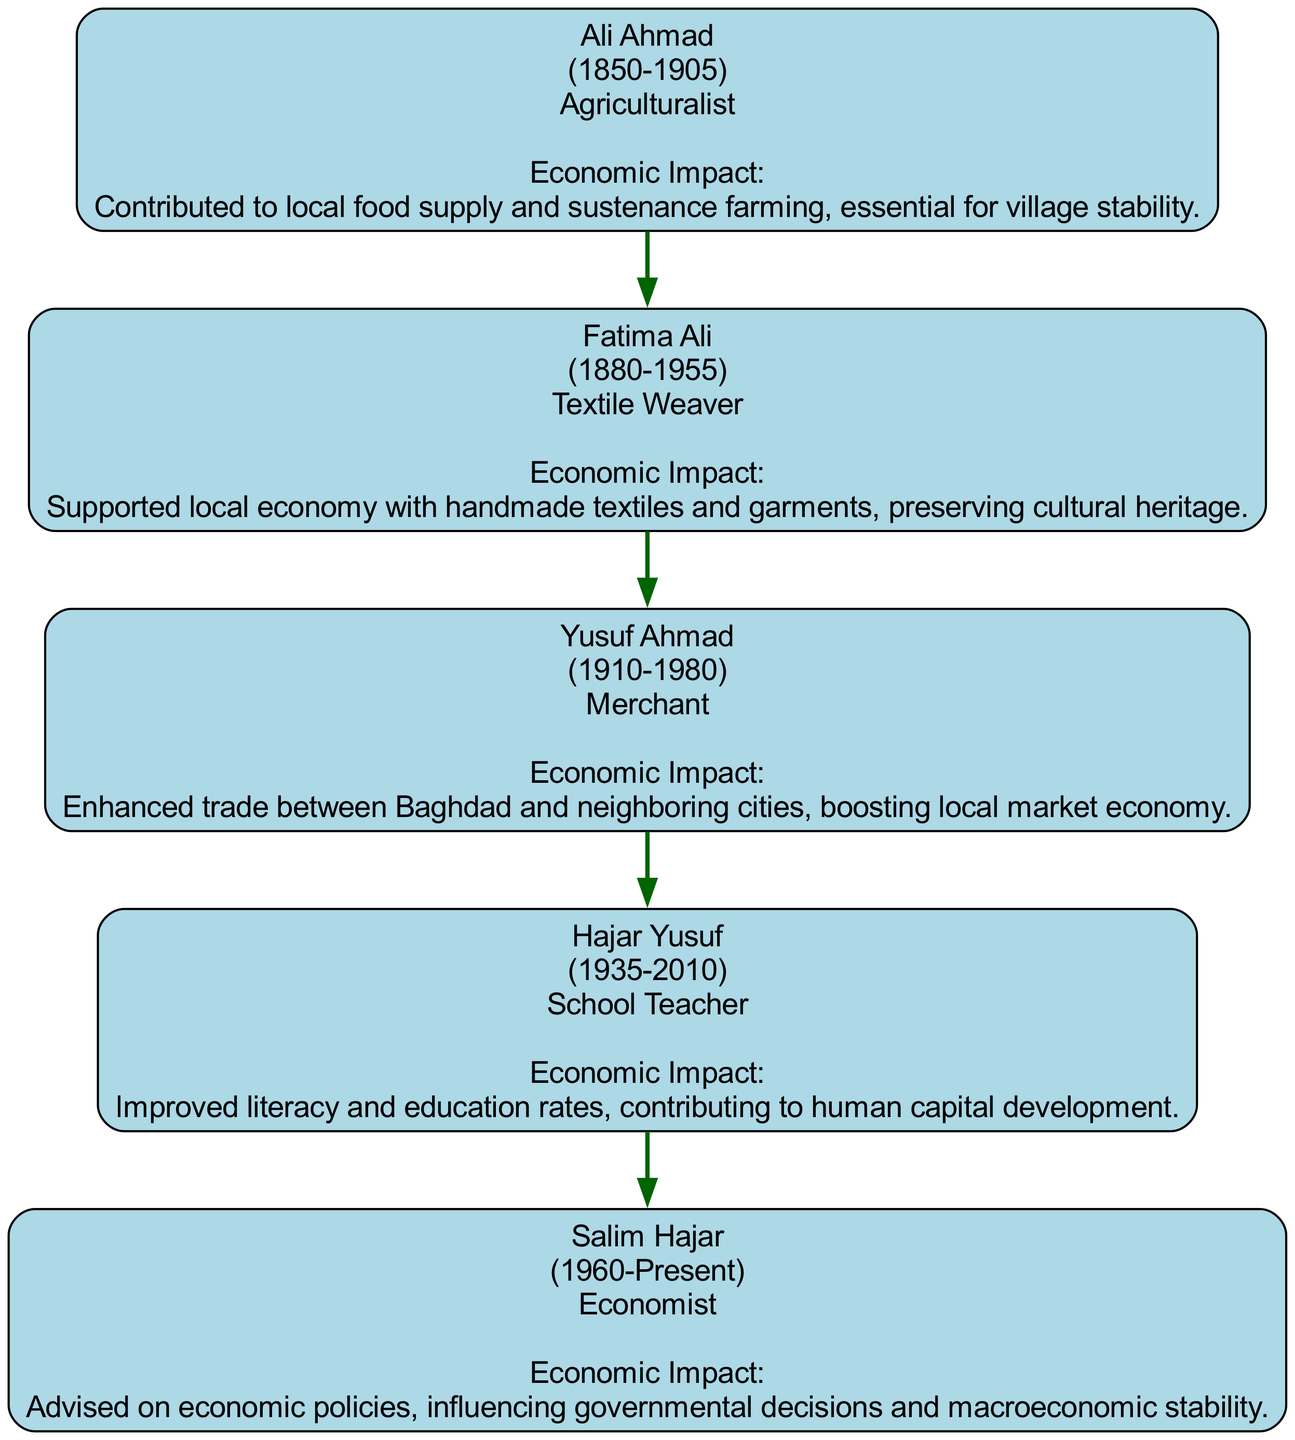What is the occupation of Ali Ahmad? The diagram clearly lists the occupation of each ancestor. For Ali Ahmad, it shows "Agriculturalist" as his occupation.
Answer: Agriculturalist How many ancestors are listed in the family tree? By counting the nodes in the diagram, we can see that there are five ancestors shown, which directly reflects the information provided.
Answer: 5 Who was the merchant in the family tree? By examining the ancestors' names and occupations, it can be noted that Yusuf Ahmad is identified as the "Merchant."
Answer: Yusuf Ahmad What was the economic impact of Hajar Yusuf's occupation? The diagram specifies that Hajar Yusuf, as a "School Teacher," had an economic impact of "Improved literacy and education rates, contributing to human capital development."
Answer: Improved literacy and education rates, contributing to human capital development Which ancestor's occupation is related to textile production? Looking at the occupations listed, Fatima Ali is the one associated with textile production, specifically as a "Textile Weaver."
Answer: Textile Weaver How did Ali Ahmad contribute to the economy? The diagram states that Ali Ahmad's economic contribution was to the "local food supply and sustenance farming," indicating his role in supporting village stability.
Answer: Local food supply and sustenance farming Who followed Yusuf Ahmad in the family tree? The diagram provides a direct lineage structure; after Yusuf Ahmad, the next ancestor listed is Hajar Yusuf, indicating the immediate relationship.
Answer: Hajar Yusuf What was Salim Hajar's economic focus? According to the diagram, Salim Hajar is an "Economist," and his economic impact involves advising on economic policies, affecting governmental decisions and macroeconomic stability.
Answer: Advising on economic policies Which ancestor lived the longest? The death years of the ancestors show that Fatima Ali, who died in 1955, lived the longest until that date, as others either died earlier or are still alive.
Answer: Fatima Ali 